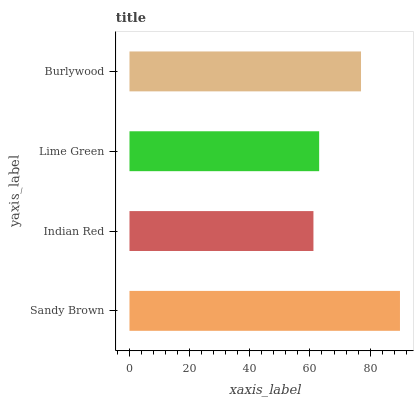Is Indian Red the minimum?
Answer yes or no. Yes. Is Sandy Brown the maximum?
Answer yes or no. Yes. Is Lime Green the minimum?
Answer yes or no. No. Is Lime Green the maximum?
Answer yes or no. No. Is Lime Green greater than Indian Red?
Answer yes or no. Yes. Is Indian Red less than Lime Green?
Answer yes or no. Yes. Is Indian Red greater than Lime Green?
Answer yes or no. No. Is Lime Green less than Indian Red?
Answer yes or no. No. Is Burlywood the high median?
Answer yes or no. Yes. Is Lime Green the low median?
Answer yes or no. Yes. Is Indian Red the high median?
Answer yes or no. No. Is Sandy Brown the low median?
Answer yes or no. No. 